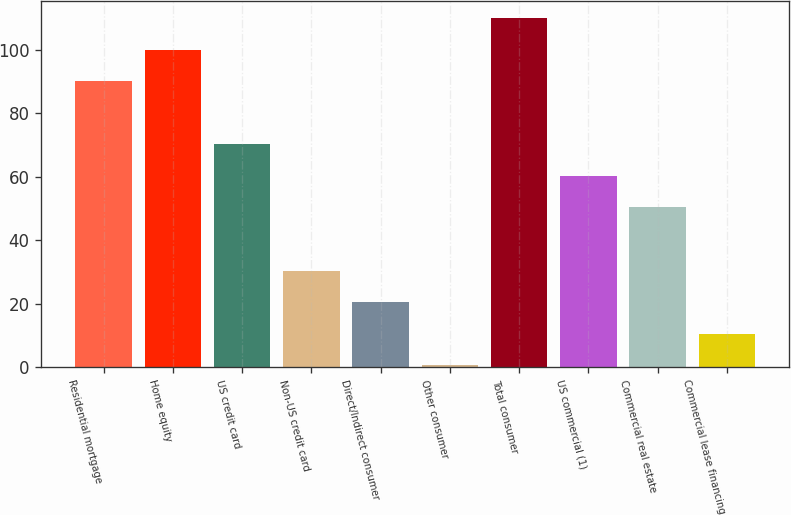Convert chart to OTSL. <chart><loc_0><loc_0><loc_500><loc_500><bar_chart><fcel>Residential mortgage<fcel>Home equity<fcel>US credit card<fcel>Non-US credit card<fcel>Direct/Indirect consumer<fcel>Other consumer<fcel>Total consumer<fcel>US commercial (1)<fcel>Commercial real estate<fcel>Commercial lease financing<nl><fcel>90.04<fcel>99.98<fcel>70.16<fcel>30.4<fcel>20.46<fcel>0.58<fcel>109.92<fcel>60.22<fcel>50.28<fcel>10.52<nl></chart> 